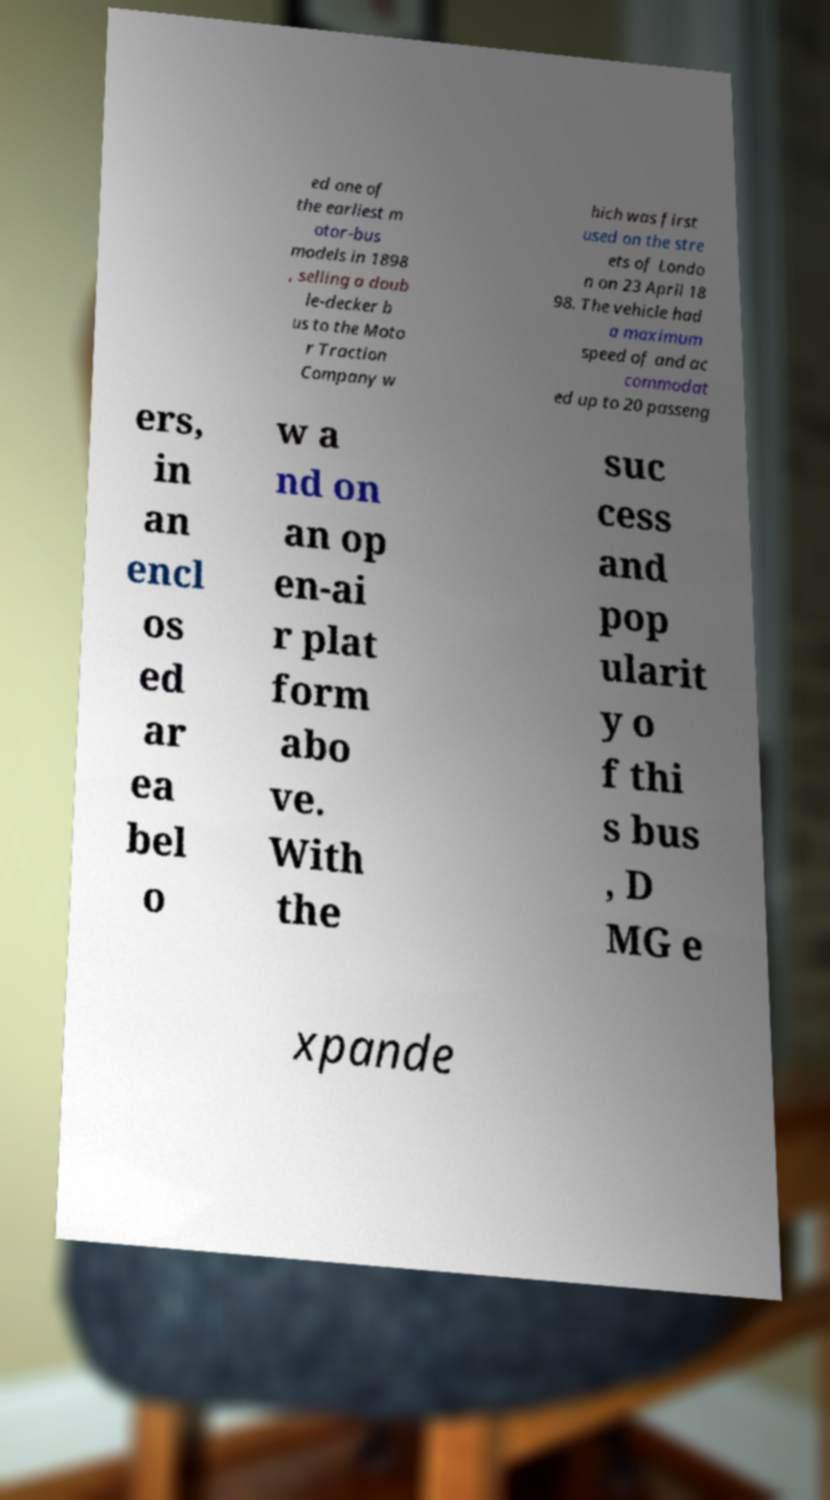There's text embedded in this image that I need extracted. Can you transcribe it verbatim? ed one of the earliest m otor-bus models in 1898 , selling a doub le-decker b us to the Moto r Traction Company w hich was first used on the stre ets of Londo n on 23 April 18 98. The vehicle had a maximum speed of and ac commodat ed up to 20 passeng ers, in an encl os ed ar ea bel o w a nd on an op en-ai r plat form abo ve. With the suc cess and pop ularit y o f thi s bus , D MG e xpande 